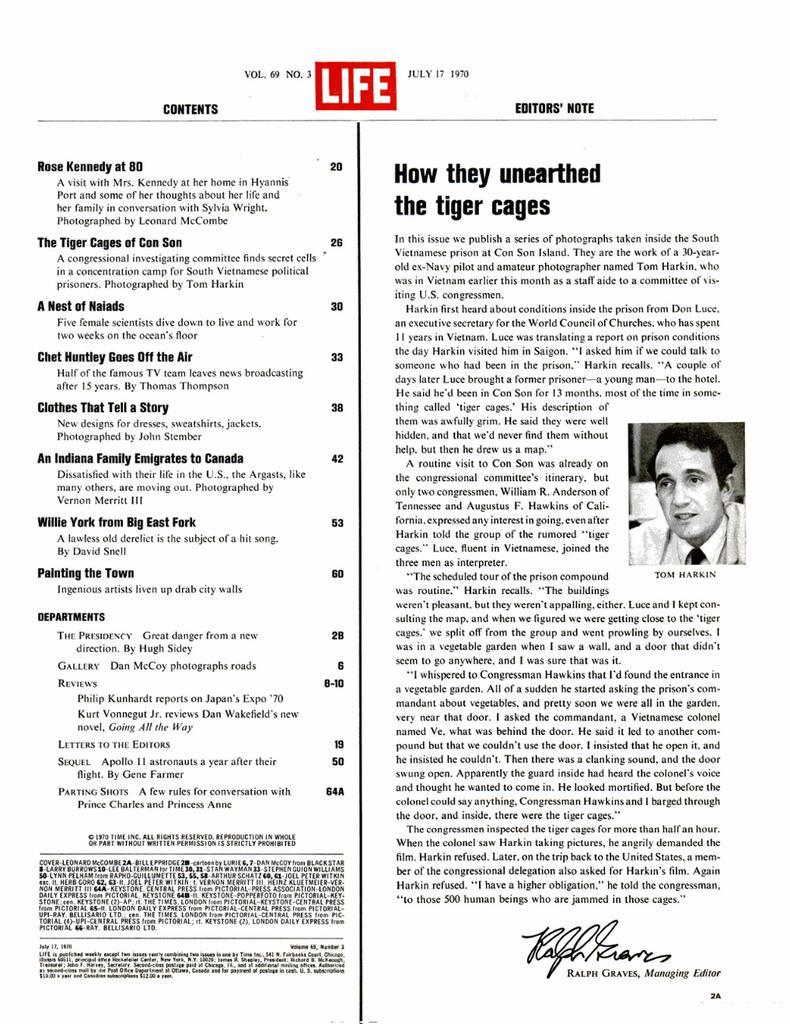What is the main subject of the image? The main subject of the image is a picture of a page. What can be found on the page in the image? The page has different contents and notes. Is there anything else visible in the image besides the page? Yes, there is a picture on the right side of the image. How many toes are visible in the image? There are no toes visible in the image. What type of lace is used to decorate the field in the image? There is no field or lace present in the image. 